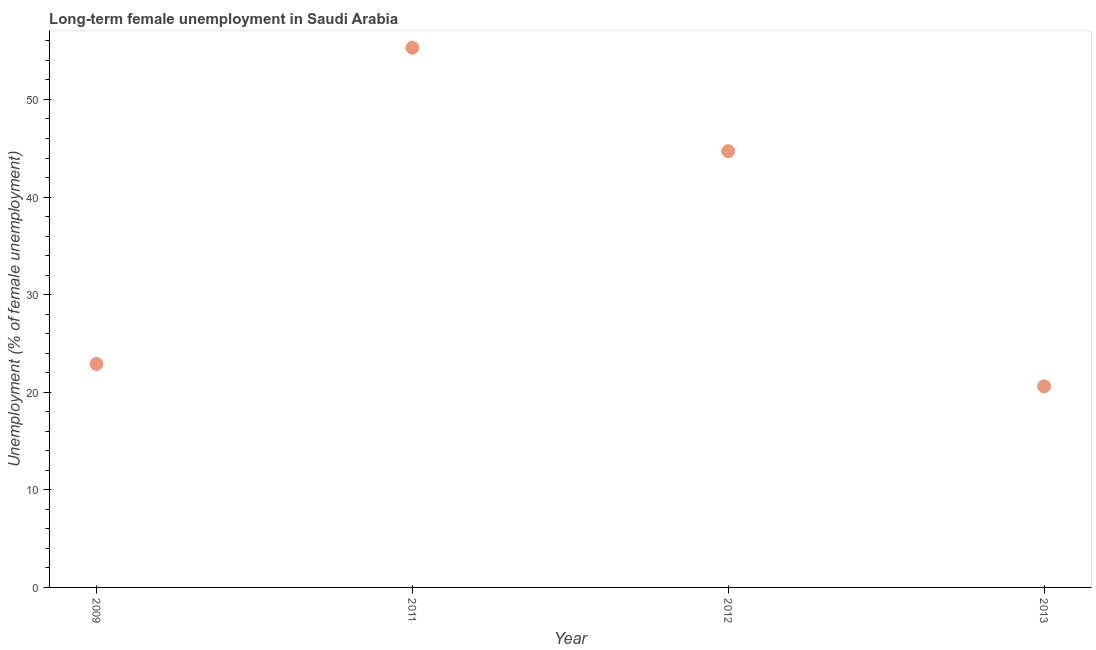What is the long-term female unemployment in 2012?
Keep it short and to the point. 44.7. Across all years, what is the maximum long-term female unemployment?
Make the answer very short. 55.3. Across all years, what is the minimum long-term female unemployment?
Give a very brief answer. 20.6. In which year was the long-term female unemployment minimum?
Provide a short and direct response. 2013. What is the sum of the long-term female unemployment?
Offer a terse response. 143.5. What is the difference between the long-term female unemployment in 2009 and 2012?
Make the answer very short. -21.8. What is the average long-term female unemployment per year?
Your response must be concise. 35.88. What is the median long-term female unemployment?
Ensure brevity in your answer.  33.8. What is the ratio of the long-term female unemployment in 2012 to that in 2013?
Make the answer very short. 2.17. Is the long-term female unemployment in 2009 less than that in 2012?
Your answer should be compact. Yes. Is the difference between the long-term female unemployment in 2009 and 2011 greater than the difference between any two years?
Make the answer very short. No. What is the difference between the highest and the second highest long-term female unemployment?
Your answer should be compact. 10.6. What is the difference between the highest and the lowest long-term female unemployment?
Your response must be concise. 34.7. Does the long-term female unemployment monotonically increase over the years?
Provide a succinct answer. No. How many dotlines are there?
Ensure brevity in your answer.  1. How many years are there in the graph?
Make the answer very short. 4. What is the difference between two consecutive major ticks on the Y-axis?
Give a very brief answer. 10. Are the values on the major ticks of Y-axis written in scientific E-notation?
Your answer should be very brief. No. Does the graph contain any zero values?
Offer a very short reply. No. What is the title of the graph?
Make the answer very short. Long-term female unemployment in Saudi Arabia. What is the label or title of the Y-axis?
Ensure brevity in your answer.  Unemployment (% of female unemployment). What is the Unemployment (% of female unemployment) in 2009?
Your answer should be compact. 22.9. What is the Unemployment (% of female unemployment) in 2011?
Your answer should be compact. 55.3. What is the Unemployment (% of female unemployment) in 2012?
Offer a terse response. 44.7. What is the Unemployment (% of female unemployment) in 2013?
Give a very brief answer. 20.6. What is the difference between the Unemployment (% of female unemployment) in 2009 and 2011?
Provide a short and direct response. -32.4. What is the difference between the Unemployment (% of female unemployment) in 2009 and 2012?
Provide a succinct answer. -21.8. What is the difference between the Unemployment (% of female unemployment) in 2011 and 2013?
Your response must be concise. 34.7. What is the difference between the Unemployment (% of female unemployment) in 2012 and 2013?
Your response must be concise. 24.1. What is the ratio of the Unemployment (% of female unemployment) in 2009 to that in 2011?
Keep it short and to the point. 0.41. What is the ratio of the Unemployment (% of female unemployment) in 2009 to that in 2012?
Provide a short and direct response. 0.51. What is the ratio of the Unemployment (% of female unemployment) in 2009 to that in 2013?
Offer a very short reply. 1.11. What is the ratio of the Unemployment (% of female unemployment) in 2011 to that in 2012?
Provide a succinct answer. 1.24. What is the ratio of the Unemployment (% of female unemployment) in 2011 to that in 2013?
Provide a short and direct response. 2.68. What is the ratio of the Unemployment (% of female unemployment) in 2012 to that in 2013?
Offer a terse response. 2.17. 